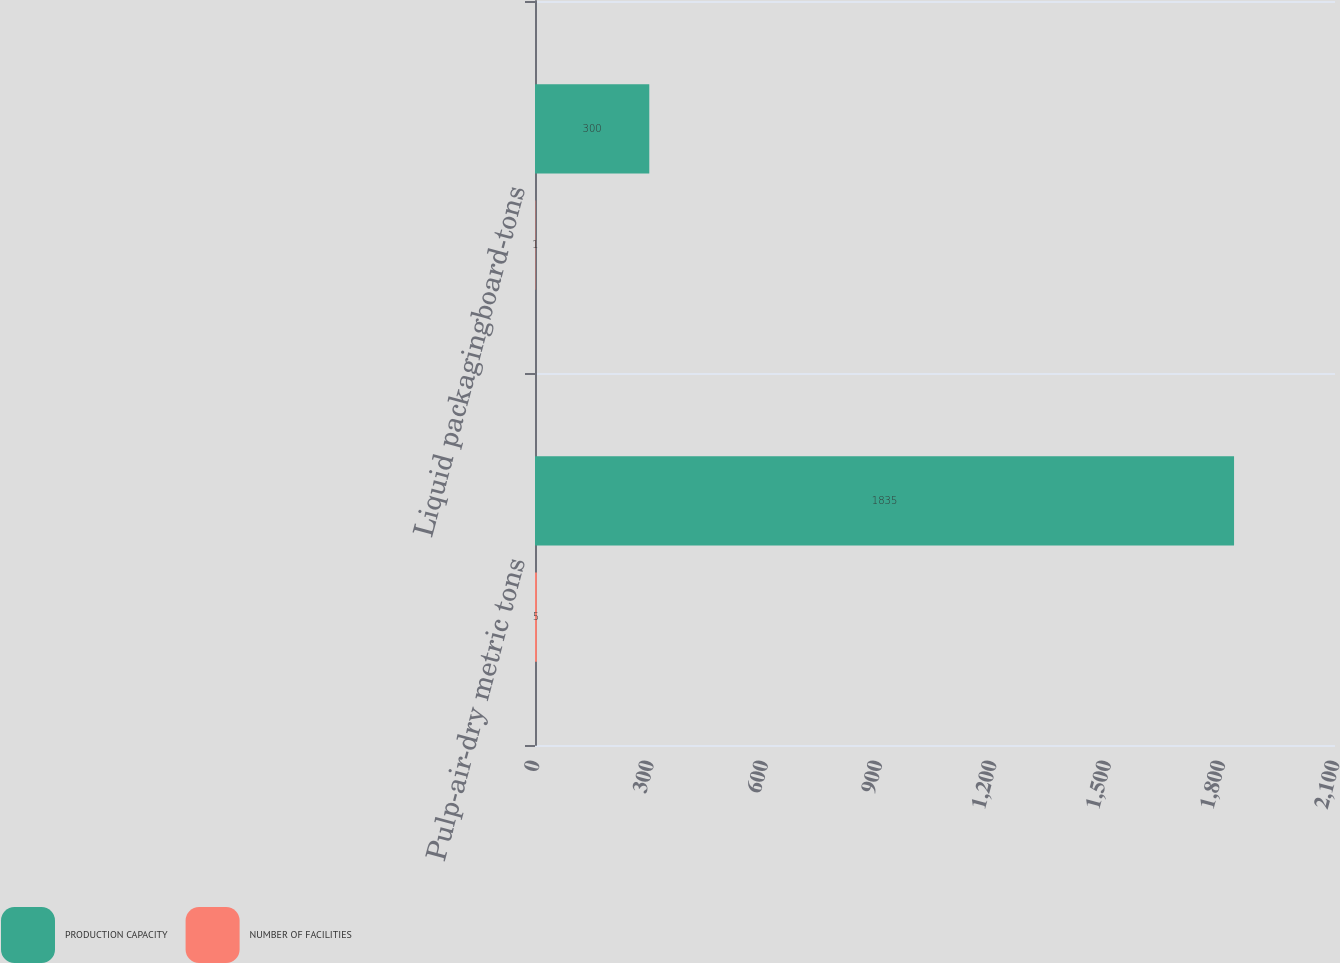<chart> <loc_0><loc_0><loc_500><loc_500><stacked_bar_chart><ecel><fcel>Pulp-air-dry metric tons<fcel>Liquid packagingboard-tons<nl><fcel>PRODUCTION CAPACITY<fcel>1835<fcel>300<nl><fcel>NUMBER OF FACILITIES<fcel>5<fcel>1<nl></chart> 